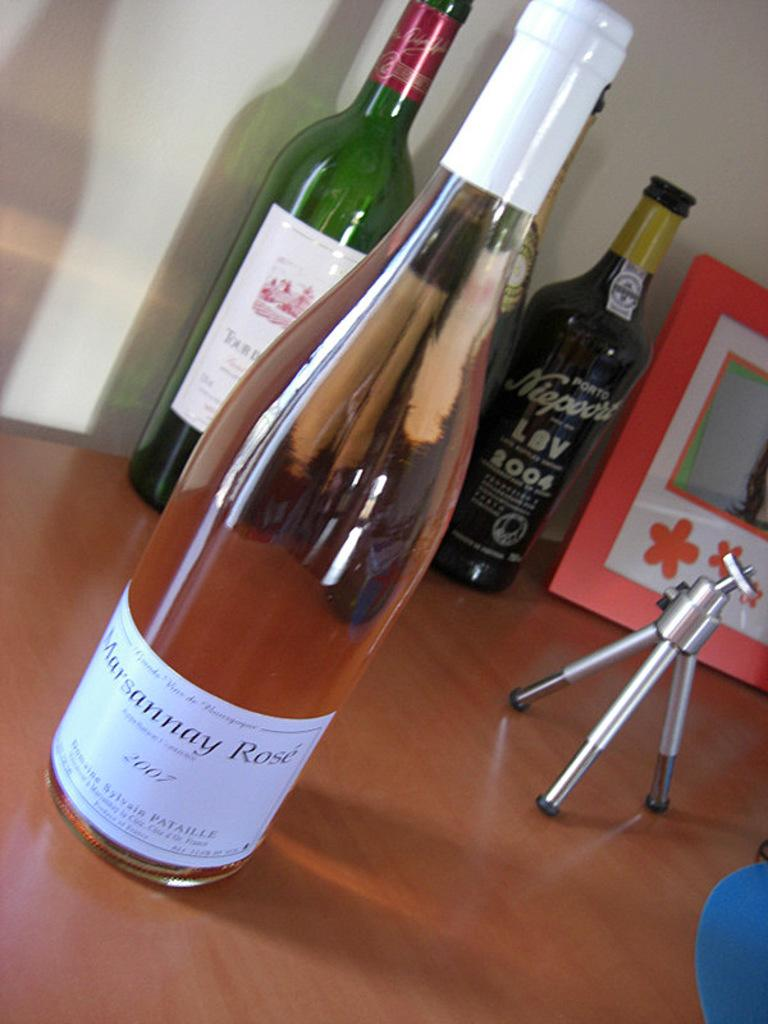<image>
Write a terse but informative summary of the picture. the word on the bottle says Rose on it 